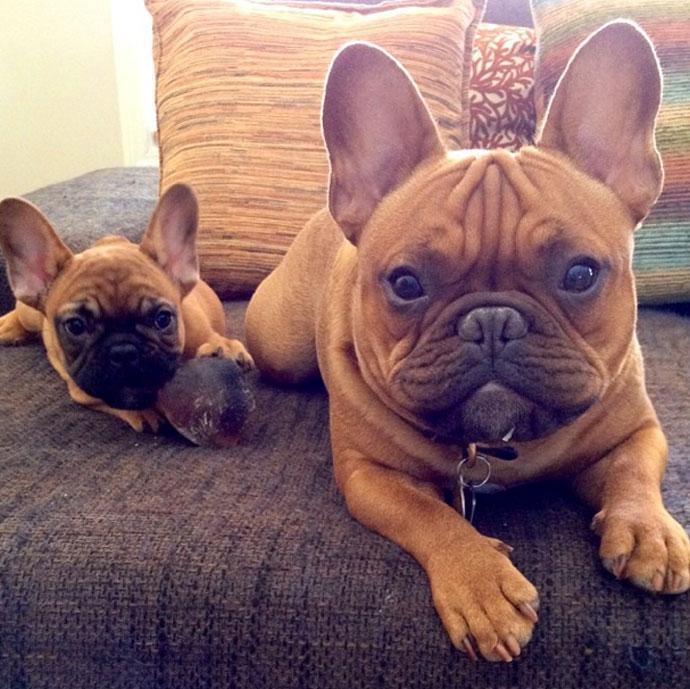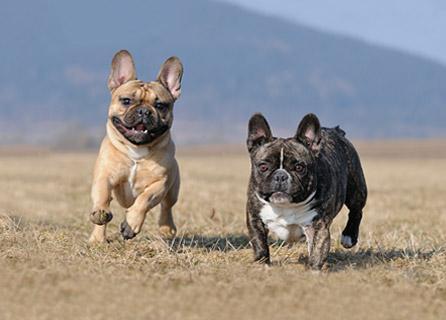The first image is the image on the left, the second image is the image on the right. Considering the images on both sides, is "There are two dogs with mouths open and tongue visible in the left image." valid? Answer yes or no. No. The first image is the image on the left, the second image is the image on the right. For the images shown, is this caption "An image shows two tan big-eared dogs posed alongside each other on a seat cushion with a burlap-like rough woven texture." true? Answer yes or no. Yes. 